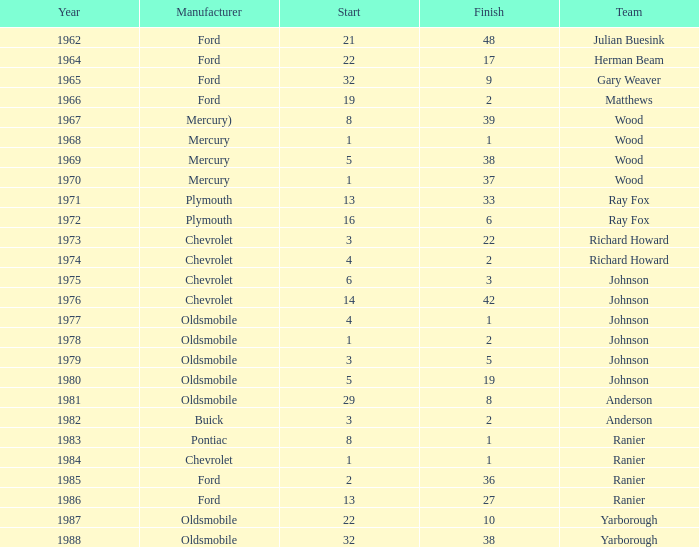What is the smallest finish time for a race where start was less than 3, buick was the manufacturer, and the race was held after 1978? None. 